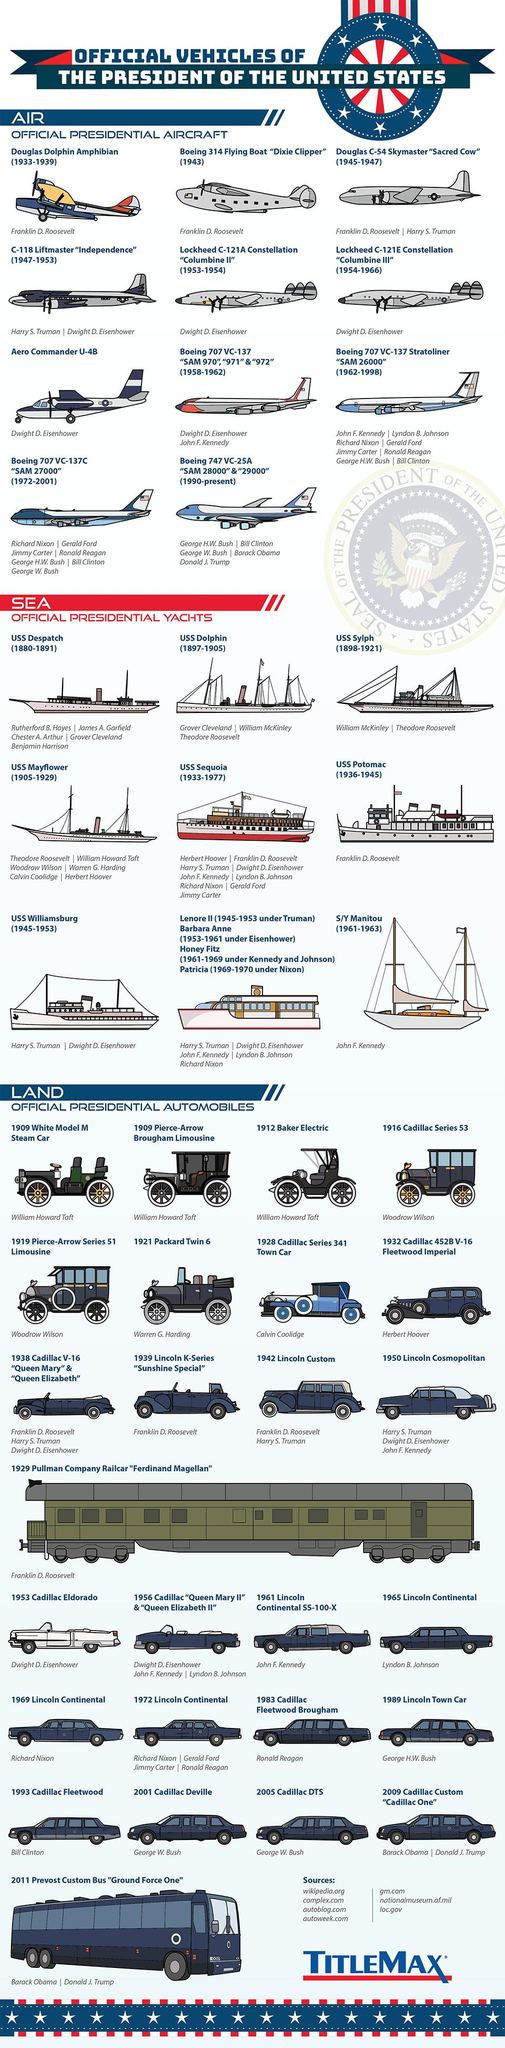Point out several critical features in this image. Jimmy Carter was the last person to use USS Sequoia. Dwight D. Eisenhower used the C-118 Liftmaster "Independence" aircraft, which was the first aircraft used by him. The USS Williamsburg was the yacht that was shared by President Harry S. Truman and President Dwight D. Eisenhower. Seven sources are listed in total. The Boeing 747 VC-25A, also known as "SAM 28000" and "29000," is currently in use. 